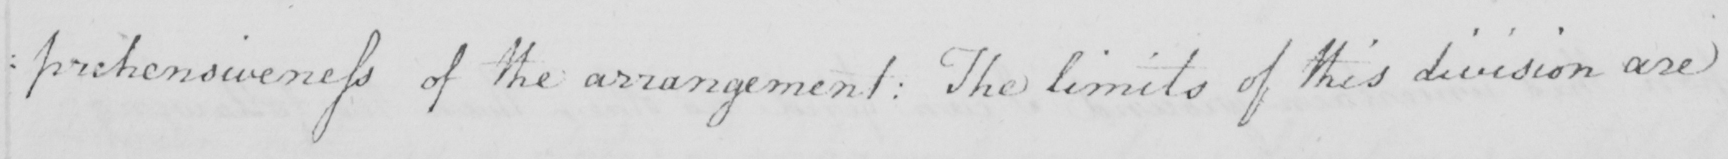Please transcribe the handwritten text in this image. : prehensiveness of the arrangement :  The limits of this division are 